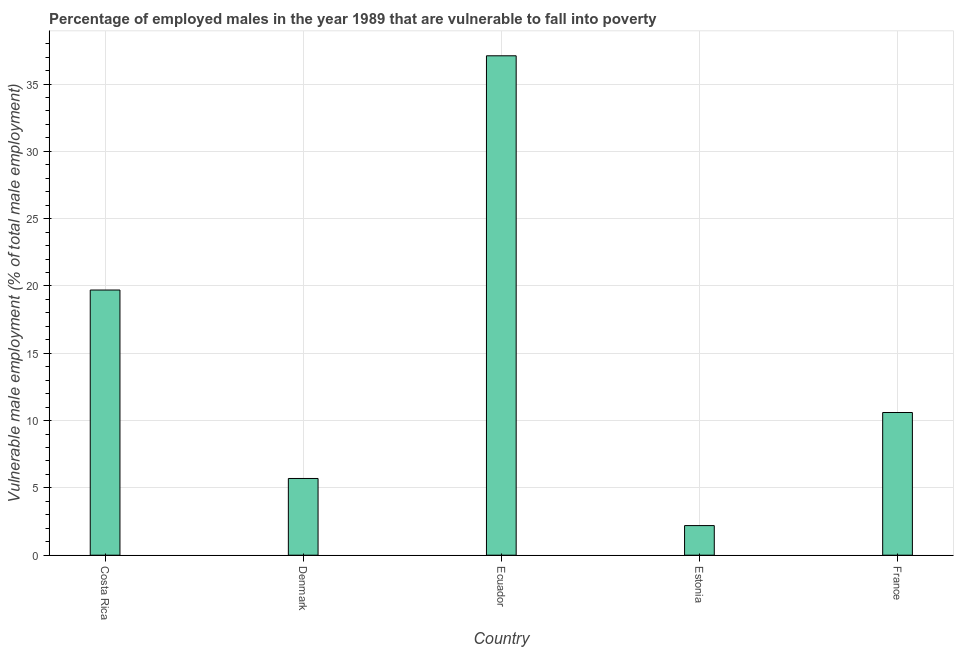Does the graph contain grids?
Offer a very short reply. Yes. What is the title of the graph?
Your answer should be compact. Percentage of employed males in the year 1989 that are vulnerable to fall into poverty. What is the label or title of the X-axis?
Offer a very short reply. Country. What is the label or title of the Y-axis?
Give a very brief answer. Vulnerable male employment (% of total male employment). What is the percentage of employed males who are vulnerable to fall into poverty in Denmark?
Your answer should be very brief. 5.7. Across all countries, what is the maximum percentage of employed males who are vulnerable to fall into poverty?
Make the answer very short. 37.1. Across all countries, what is the minimum percentage of employed males who are vulnerable to fall into poverty?
Ensure brevity in your answer.  2.2. In which country was the percentage of employed males who are vulnerable to fall into poverty maximum?
Keep it short and to the point. Ecuador. In which country was the percentage of employed males who are vulnerable to fall into poverty minimum?
Ensure brevity in your answer.  Estonia. What is the sum of the percentage of employed males who are vulnerable to fall into poverty?
Your answer should be very brief. 75.3. What is the difference between the percentage of employed males who are vulnerable to fall into poverty in Denmark and France?
Provide a succinct answer. -4.9. What is the average percentage of employed males who are vulnerable to fall into poverty per country?
Provide a succinct answer. 15.06. What is the median percentage of employed males who are vulnerable to fall into poverty?
Offer a terse response. 10.6. In how many countries, is the percentage of employed males who are vulnerable to fall into poverty greater than 18 %?
Keep it short and to the point. 2. What is the ratio of the percentage of employed males who are vulnerable to fall into poverty in Denmark to that in Ecuador?
Your response must be concise. 0.15. Is the percentage of employed males who are vulnerable to fall into poverty in Costa Rica less than that in Ecuador?
Ensure brevity in your answer.  Yes. Is the difference between the percentage of employed males who are vulnerable to fall into poverty in Costa Rica and France greater than the difference between any two countries?
Your response must be concise. No. What is the difference between the highest and the lowest percentage of employed males who are vulnerable to fall into poverty?
Ensure brevity in your answer.  34.9. How many countries are there in the graph?
Your answer should be compact. 5. What is the Vulnerable male employment (% of total male employment) of Costa Rica?
Give a very brief answer. 19.7. What is the Vulnerable male employment (% of total male employment) of Denmark?
Keep it short and to the point. 5.7. What is the Vulnerable male employment (% of total male employment) in Ecuador?
Your answer should be compact. 37.1. What is the Vulnerable male employment (% of total male employment) in Estonia?
Ensure brevity in your answer.  2.2. What is the Vulnerable male employment (% of total male employment) in France?
Provide a short and direct response. 10.6. What is the difference between the Vulnerable male employment (% of total male employment) in Costa Rica and Ecuador?
Offer a terse response. -17.4. What is the difference between the Vulnerable male employment (% of total male employment) in Denmark and Ecuador?
Ensure brevity in your answer.  -31.4. What is the difference between the Vulnerable male employment (% of total male employment) in Denmark and Estonia?
Ensure brevity in your answer.  3.5. What is the difference between the Vulnerable male employment (% of total male employment) in Denmark and France?
Give a very brief answer. -4.9. What is the difference between the Vulnerable male employment (% of total male employment) in Ecuador and Estonia?
Make the answer very short. 34.9. What is the difference between the Vulnerable male employment (% of total male employment) in Ecuador and France?
Your answer should be compact. 26.5. What is the ratio of the Vulnerable male employment (% of total male employment) in Costa Rica to that in Denmark?
Ensure brevity in your answer.  3.46. What is the ratio of the Vulnerable male employment (% of total male employment) in Costa Rica to that in Ecuador?
Make the answer very short. 0.53. What is the ratio of the Vulnerable male employment (% of total male employment) in Costa Rica to that in Estonia?
Give a very brief answer. 8.96. What is the ratio of the Vulnerable male employment (% of total male employment) in Costa Rica to that in France?
Provide a short and direct response. 1.86. What is the ratio of the Vulnerable male employment (% of total male employment) in Denmark to that in Ecuador?
Make the answer very short. 0.15. What is the ratio of the Vulnerable male employment (% of total male employment) in Denmark to that in Estonia?
Ensure brevity in your answer.  2.59. What is the ratio of the Vulnerable male employment (% of total male employment) in Denmark to that in France?
Keep it short and to the point. 0.54. What is the ratio of the Vulnerable male employment (% of total male employment) in Ecuador to that in Estonia?
Provide a short and direct response. 16.86. What is the ratio of the Vulnerable male employment (% of total male employment) in Ecuador to that in France?
Ensure brevity in your answer.  3.5. What is the ratio of the Vulnerable male employment (% of total male employment) in Estonia to that in France?
Keep it short and to the point. 0.21. 